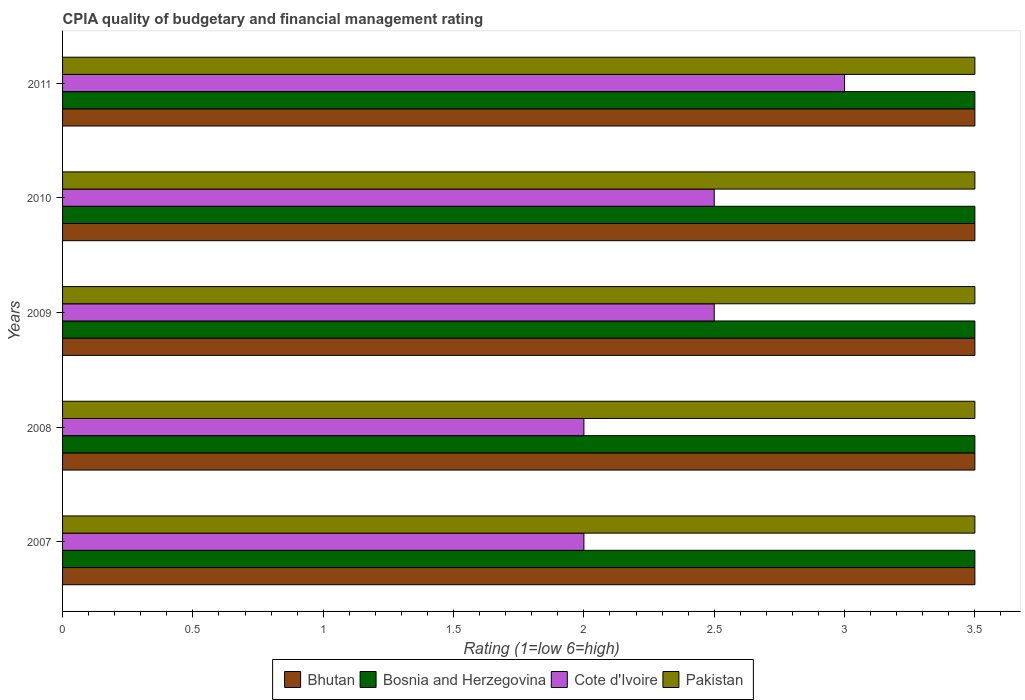How many different coloured bars are there?
Keep it short and to the point. 4. How many groups of bars are there?
Make the answer very short. 5. Are the number of bars per tick equal to the number of legend labels?
Your answer should be compact. Yes. How many bars are there on the 3rd tick from the bottom?
Offer a very short reply. 4. What is the label of the 5th group of bars from the top?
Your answer should be compact. 2007. What is the CPIA rating in Cote d'Ivoire in 2011?
Provide a short and direct response. 3. Across all years, what is the minimum CPIA rating in Bosnia and Herzegovina?
Make the answer very short. 3.5. What is the average CPIA rating in Bhutan per year?
Provide a succinct answer. 3.5. In the year 2010, what is the difference between the CPIA rating in Cote d'Ivoire and CPIA rating in Bosnia and Herzegovina?
Your response must be concise. -1. In how many years, is the CPIA rating in Cote d'Ivoire greater than 2.4 ?
Provide a short and direct response. 3. What is the ratio of the CPIA rating in Cote d'Ivoire in 2010 to that in 2011?
Ensure brevity in your answer.  0.83. In how many years, is the CPIA rating in Bosnia and Herzegovina greater than the average CPIA rating in Bosnia and Herzegovina taken over all years?
Provide a succinct answer. 0. Is it the case that in every year, the sum of the CPIA rating in Bhutan and CPIA rating in Bosnia and Herzegovina is greater than the sum of CPIA rating in Cote d'Ivoire and CPIA rating in Pakistan?
Provide a succinct answer. No. What does the 3rd bar from the top in 2011 represents?
Offer a terse response. Bosnia and Herzegovina. What does the 1st bar from the bottom in 2009 represents?
Your answer should be compact. Bhutan. Is it the case that in every year, the sum of the CPIA rating in Cote d'Ivoire and CPIA rating in Bhutan is greater than the CPIA rating in Pakistan?
Offer a terse response. Yes. How many bars are there?
Offer a very short reply. 20. What is the difference between two consecutive major ticks on the X-axis?
Offer a terse response. 0.5. Are the values on the major ticks of X-axis written in scientific E-notation?
Ensure brevity in your answer.  No. Does the graph contain grids?
Your answer should be compact. No. How many legend labels are there?
Make the answer very short. 4. What is the title of the graph?
Your response must be concise. CPIA quality of budgetary and financial management rating. Does "Macao" appear as one of the legend labels in the graph?
Give a very brief answer. No. What is the label or title of the X-axis?
Your answer should be very brief. Rating (1=low 6=high). What is the label or title of the Y-axis?
Provide a short and direct response. Years. What is the Rating (1=low 6=high) in Bosnia and Herzegovina in 2007?
Give a very brief answer. 3.5. What is the Rating (1=low 6=high) of Cote d'Ivoire in 2007?
Your answer should be very brief. 2. What is the Rating (1=low 6=high) in Bhutan in 2008?
Offer a very short reply. 3.5. What is the Rating (1=low 6=high) of Bosnia and Herzegovina in 2008?
Provide a succinct answer. 3.5. What is the Rating (1=low 6=high) in Cote d'Ivoire in 2008?
Offer a terse response. 2. What is the Rating (1=low 6=high) in Pakistan in 2008?
Provide a succinct answer. 3.5. What is the Rating (1=low 6=high) in Bosnia and Herzegovina in 2010?
Offer a terse response. 3.5. What is the Rating (1=low 6=high) in Cote d'Ivoire in 2010?
Offer a terse response. 2.5. What is the Rating (1=low 6=high) in Pakistan in 2010?
Provide a short and direct response. 3.5. Across all years, what is the minimum Rating (1=low 6=high) in Bhutan?
Your response must be concise. 3.5. Across all years, what is the minimum Rating (1=low 6=high) of Bosnia and Herzegovina?
Offer a very short reply. 3.5. What is the total Rating (1=low 6=high) of Bhutan in the graph?
Offer a very short reply. 17.5. What is the total Rating (1=low 6=high) in Bosnia and Herzegovina in the graph?
Provide a succinct answer. 17.5. What is the difference between the Rating (1=low 6=high) of Bosnia and Herzegovina in 2007 and that in 2008?
Offer a very short reply. 0. What is the difference between the Rating (1=low 6=high) in Pakistan in 2007 and that in 2008?
Offer a terse response. 0. What is the difference between the Rating (1=low 6=high) in Bosnia and Herzegovina in 2007 and that in 2009?
Ensure brevity in your answer.  0. What is the difference between the Rating (1=low 6=high) of Cote d'Ivoire in 2007 and that in 2010?
Make the answer very short. -0.5. What is the difference between the Rating (1=low 6=high) in Bhutan in 2007 and that in 2011?
Keep it short and to the point. 0. What is the difference between the Rating (1=low 6=high) of Bosnia and Herzegovina in 2007 and that in 2011?
Offer a terse response. 0. What is the difference between the Rating (1=low 6=high) in Bhutan in 2008 and that in 2009?
Keep it short and to the point. 0. What is the difference between the Rating (1=low 6=high) of Cote d'Ivoire in 2008 and that in 2010?
Make the answer very short. -0.5. What is the difference between the Rating (1=low 6=high) in Bhutan in 2008 and that in 2011?
Ensure brevity in your answer.  0. What is the difference between the Rating (1=low 6=high) in Cote d'Ivoire in 2008 and that in 2011?
Provide a succinct answer. -1. What is the difference between the Rating (1=low 6=high) in Bhutan in 2009 and that in 2010?
Give a very brief answer. 0. What is the difference between the Rating (1=low 6=high) of Bosnia and Herzegovina in 2009 and that in 2010?
Provide a succinct answer. 0. What is the difference between the Rating (1=low 6=high) of Cote d'Ivoire in 2009 and that in 2010?
Offer a terse response. 0. What is the difference between the Rating (1=low 6=high) in Bosnia and Herzegovina in 2009 and that in 2011?
Your answer should be very brief. 0. What is the difference between the Rating (1=low 6=high) in Cote d'Ivoire in 2009 and that in 2011?
Provide a short and direct response. -0.5. What is the difference between the Rating (1=low 6=high) of Pakistan in 2009 and that in 2011?
Give a very brief answer. 0. What is the difference between the Rating (1=low 6=high) in Bhutan in 2007 and the Rating (1=low 6=high) in Bosnia and Herzegovina in 2008?
Ensure brevity in your answer.  0. What is the difference between the Rating (1=low 6=high) in Bhutan in 2007 and the Rating (1=low 6=high) in Cote d'Ivoire in 2008?
Provide a succinct answer. 1.5. What is the difference between the Rating (1=low 6=high) of Bhutan in 2007 and the Rating (1=low 6=high) of Pakistan in 2008?
Give a very brief answer. 0. What is the difference between the Rating (1=low 6=high) of Bosnia and Herzegovina in 2007 and the Rating (1=low 6=high) of Cote d'Ivoire in 2008?
Give a very brief answer. 1.5. What is the difference between the Rating (1=low 6=high) of Bosnia and Herzegovina in 2007 and the Rating (1=low 6=high) of Pakistan in 2008?
Ensure brevity in your answer.  0. What is the difference between the Rating (1=low 6=high) of Bhutan in 2007 and the Rating (1=low 6=high) of Bosnia and Herzegovina in 2009?
Your answer should be very brief. 0. What is the difference between the Rating (1=low 6=high) of Bosnia and Herzegovina in 2007 and the Rating (1=low 6=high) of Pakistan in 2009?
Ensure brevity in your answer.  0. What is the difference between the Rating (1=low 6=high) in Cote d'Ivoire in 2007 and the Rating (1=low 6=high) in Pakistan in 2009?
Offer a very short reply. -1.5. What is the difference between the Rating (1=low 6=high) of Bhutan in 2007 and the Rating (1=low 6=high) of Bosnia and Herzegovina in 2010?
Your answer should be compact. 0. What is the difference between the Rating (1=low 6=high) in Bhutan in 2007 and the Rating (1=low 6=high) in Pakistan in 2010?
Your answer should be very brief. 0. What is the difference between the Rating (1=low 6=high) of Bosnia and Herzegovina in 2007 and the Rating (1=low 6=high) of Cote d'Ivoire in 2010?
Offer a very short reply. 1. What is the difference between the Rating (1=low 6=high) in Bosnia and Herzegovina in 2007 and the Rating (1=low 6=high) in Pakistan in 2010?
Your answer should be very brief. 0. What is the difference between the Rating (1=low 6=high) in Bhutan in 2007 and the Rating (1=low 6=high) in Bosnia and Herzegovina in 2011?
Your response must be concise. 0. What is the difference between the Rating (1=low 6=high) in Bhutan in 2007 and the Rating (1=low 6=high) in Cote d'Ivoire in 2011?
Your answer should be very brief. 0.5. What is the difference between the Rating (1=low 6=high) of Bosnia and Herzegovina in 2007 and the Rating (1=low 6=high) of Cote d'Ivoire in 2011?
Your answer should be compact. 0.5. What is the difference between the Rating (1=low 6=high) in Bosnia and Herzegovina in 2007 and the Rating (1=low 6=high) in Pakistan in 2011?
Offer a very short reply. 0. What is the difference between the Rating (1=low 6=high) of Cote d'Ivoire in 2008 and the Rating (1=low 6=high) of Pakistan in 2009?
Your answer should be very brief. -1.5. What is the difference between the Rating (1=low 6=high) in Bhutan in 2008 and the Rating (1=low 6=high) in Bosnia and Herzegovina in 2010?
Keep it short and to the point. 0. What is the difference between the Rating (1=low 6=high) of Bhutan in 2008 and the Rating (1=low 6=high) of Cote d'Ivoire in 2010?
Your response must be concise. 1. What is the difference between the Rating (1=low 6=high) in Bhutan in 2008 and the Rating (1=low 6=high) in Pakistan in 2010?
Offer a very short reply. 0. What is the difference between the Rating (1=low 6=high) of Bosnia and Herzegovina in 2008 and the Rating (1=low 6=high) of Pakistan in 2010?
Offer a terse response. 0. What is the difference between the Rating (1=low 6=high) of Cote d'Ivoire in 2008 and the Rating (1=low 6=high) of Pakistan in 2010?
Make the answer very short. -1.5. What is the difference between the Rating (1=low 6=high) in Bhutan in 2008 and the Rating (1=low 6=high) in Bosnia and Herzegovina in 2011?
Your answer should be very brief. 0. What is the difference between the Rating (1=low 6=high) of Bhutan in 2008 and the Rating (1=low 6=high) of Cote d'Ivoire in 2011?
Give a very brief answer. 0.5. What is the difference between the Rating (1=low 6=high) of Bhutan in 2008 and the Rating (1=low 6=high) of Pakistan in 2011?
Your response must be concise. 0. What is the difference between the Rating (1=low 6=high) in Bosnia and Herzegovina in 2008 and the Rating (1=low 6=high) in Cote d'Ivoire in 2011?
Make the answer very short. 0.5. What is the difference between the Rating (1=low 6=high) in Bhutan in 2009 and the Rating (1=low 6=high) in Cote d'Ivoire in 2010?
Make the answer very short. 1. What is the difference between the Rating (1=low 6=high) in Bosnia and Herzegovina in 2009 and the Rating (1=low 6=high) in Cote d'Ivoire in 2010?
Keep it short and to the point. 1. What is the difference between the Rating (1=low 6=high) in Bosnia and Herzegovina in 2009 and the Rating (1=low 6=high) in Pakistan in 2010?
Your response must be concise. 0. What is the difference between the Rating (1=low 6=high) in Cote d'Ivoire in 2009 and the Rating (1=low 6=high) in Pakistan in 2010?
Your answer should be very brief. -1. What is the difference between the Rating (1=low 6=high) of Bhutan in 2009 and the Rating (1=low 6=high) of Bosnia and Herzegovina in 2011?
Your response must be concise. 0. What is the difference between the Rating (1=low 6=high) of Bhutan in 2009 and the Rating (1=low 6=high) of Pakistan in 2011?
Your response must be concise. 0. What is the difference between the Rating (1=low 6=high) of Cote d'Ivoire in 2009 and the Rating (1=low 6=high) of Pakistan in 2011?
Your answer should be compact. -1. What is the difference between the Rating (1=low 6=high) in Bhutan in 2010 and the Rating (1=low 6=high) in Cote d'Ivoire in 2011?
Ensure brevity in your answer.  0.5. What is the average Rating (1=low 6=high) of Bosnia and Herzegovina per year?
Ensure brevity in your answer.  3.5. In the year 2007, what is the difference between the Rating (1=low 6=high) in Bhutan and Rating (1=low 6=high) in Bosnia and Herzegovina?
Your answer should be very brief. 0. In the year 2007, what is the difference between the Rating (1=low 6=high) in Bhutan and Rating (1=low 6=high) in Cote d'Ivoire?
Provide a short and direct response. 1.5. In the year 2007, what is the difference between the Rating (1=low 6=high) of Bosnia and Herzegovina and Rating (1=low 6=high) of Pakistan?
Keep it short and to the point. 0. In the year 2008, what is the difference between the Rating (1=low 6=high) in Bhutan and Rating (1=low 6=high) in Bosnia and Herzegovina?
Ensure brevity in your answer.  0. In the year 2008, what is the difference between the Rating (1=low 6=high) of Bhutan and Rating (1=low 6=high) of Cote d'Ivoire?
Give a very brief answer. 1.5. In the year 2008, what is the difference between the Rating (1=low 6=high) in Bosnia and Herzegovina and Rating (1=low 6=high) in Pakistan?
Your response must be concise. 0. In the year 2009, what is the difference between the Rating (1=low 6=high) in Bhutan and Rating (1=low 6=high) in Cote d'Ivoire?
Provide a succinct answer. 1. In the year 2009, what is the difference between the Rating (1=low 6=high) of Bosnia and Herzegovina and Rating (1=low 6=high) of Pakistan?
Your answer should be compact. 0. In the year 2010, what is the difference between the Rating (1=low 6=high) in Bhutan and Rating (1=low 6=high) in Bosnia and Herzegovina?
Your answer should be compact. 0. In the year 2010, what is the difference between the Rating (1=low 6=high) in Bhutan and Rating (1=low 6=high) in Cote d'Ivoire?
Your answer should be very brief. 1. In the year 2010, what is the difference between the Rating (1=low 6=high) in Bhutan and Rating (1=low 6=high) in Pakistan?
Offer a very short reply. 0. In the year 2010, what is the difference between the Rating (1=low 6=high) in Cote d'Ivoire and Rating (1=low 6=high) in Pakistan?
Offer a very short reply. -1. In the year 2011, what is the difference between the Rating (1=low 6=high) in Bhutan and Rating (1=low 6=high) in Bosnia and Herzegovina?
Provide a short and direct response. 0. In the year 2011, what is the difference between the Rating (1=low 6=high) of Bosnia and Herzegovina and Rating (1=low 6=high) of Pakistan?
Your answer should be compact. 0. What is the ratio of the Rating (1=low 6=high) of Bosnia and Herzegovina in 2007 to that in 2008?
Ensure brevity in your answer.  1. What is the ratio of the Rating (1=low 6=high) of Bosnia and Herzegovina in 2007 to that in 2009?
Provide a short and direct response. 1. What is the ratio of the Rating (1=low 6=high) in Cote d'Ivoire in 2007 to that in 2009?
Give a very brief answer. 0.8. What is the ratio of the Rating (1=low 6=high) in Bosnia and Herzegovina in 2007 to that in 2011?
Ensure brevity in your answer.  1. What is the ratio of the Rating (1=low 6=high) of Pakistan in 2008 to that in 2009?
Provide a succinct answer. 1. What is the ratio of the Rating (1=low 6=high) of Bosnia and Herzegovina in 2008 to that in 2010?
Ensure brevity in your answer.  1. What is the ratio of the Rating (1=low 6=high) of Pakistan in 2008 to that in 2010?
Keep it short and to the point. 1. What is the ratio of the Rating (1=low 6=high) in Bhutan in 2008 to that in 2011?
Provide a succinct answer. 1. What is the ratio of the Rating (1=low 6=high) in Bosnia and Herzegovina in 2008 to that in 2011?
Make the answer very short. 1. What is the ratio of the Rating (1=low 6=high) of Pakistan in 2008 to that in 2011?
Your answer should be very brief. 1. What is the ratio of the Rating (1=low 6=high) in Cote d'Ivoire in 2009 to that in 2010?
Your answer should be compact. 1. What is the ratio of the Rating (1=low 6=high) in Bosnia and Herzegovina in 2009 to that in 2011?
Your response must be concise. 1. What is the ratio of the Rating (1=low 6=high) of Bhutan in 2010 to that in 2011?
Give a very brief answer. 1. What is the ratio of the Rating (1=low 6=high) of Cote d'Ivoire in 2010 to that in 2011?
Offer a very short reply. 0.83. What is the ratio of the Rating (1=low 6=high) in Pakistan in 2010 to that in 2011?
Provide a succinct answer. 1. What is the difference between the highest and the second highest Rating (1=low 6=high) of Bhutan?
Provide a succinct answer. 0. What is the difference between the highest and the second highest Rating (1=low 6=high) in Bosnia and Herzegovina?
Make the answer very short. 0. What is the difference between the highest and the second highest Rating (1=low 6=high) of Pakistan?
Give a very brief answer. 0. What is the difference between the highest and the lowest Rating (1=low 6=high) of Bhutan?
Provide a succinct answer. 0. What is the difference between the highest and the lowest Rating (1=low 6=high) of Cote d'Ivoire?
Your answer should be very brief. 1. What is the difference between the highest and the lowest Rating (1=low 6=high) of Pakistan?
Offer a terse response. 0. 